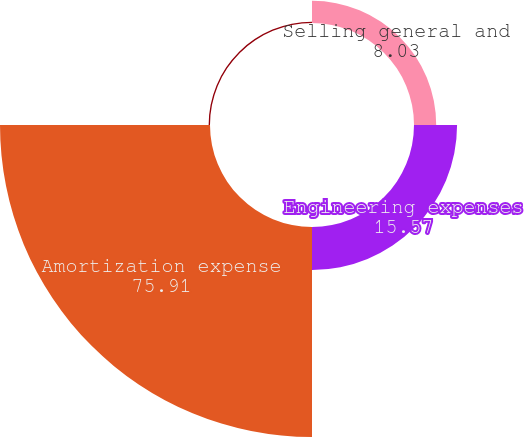Convert chart. <chart><loc_0><loc_0><loc_500><loc_500><pie_chart><fcel>Selling general and<fcel>Engineering expenses<fcel>Amortization expense<fcel>Total operating expenses<nl><fcel>8.03%<fcel>15.57%<fcel>75.91%<fcel>0.49%<nl></chart> 